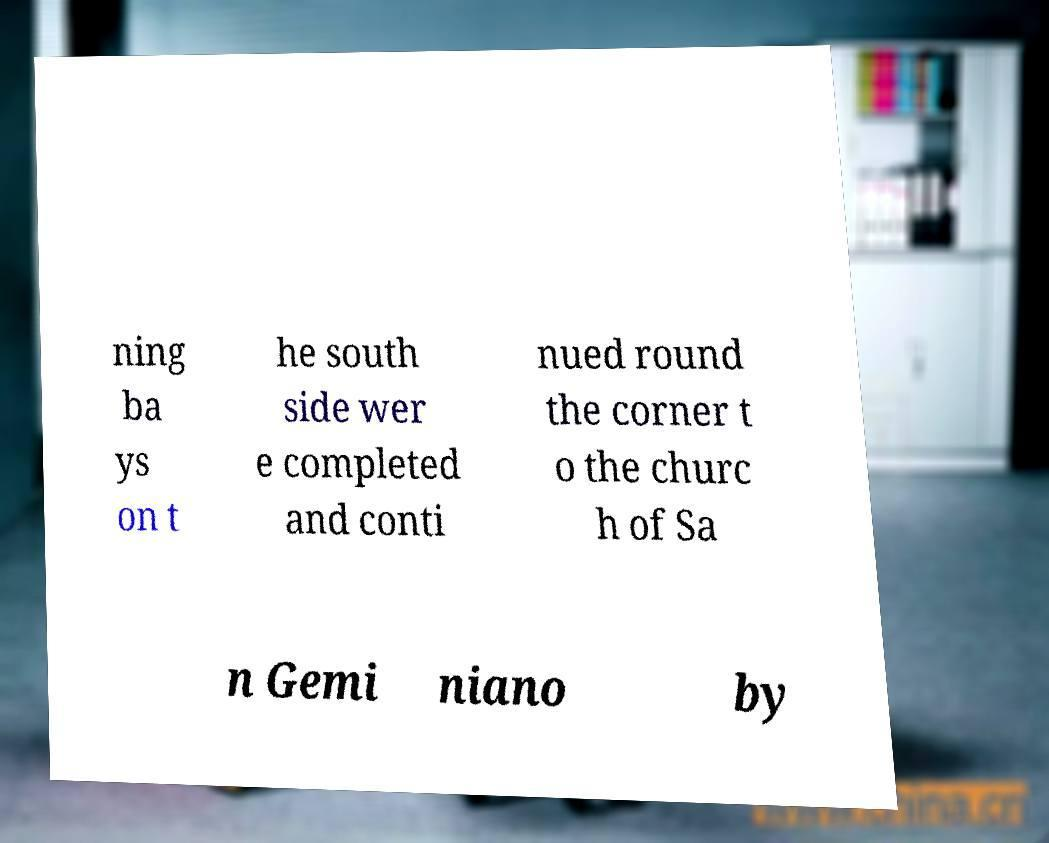Could you extract and type out the text from this image? ning ba ys on t he south side wer e completed and conti nued round the corner t o the churc h of Sa n Gemi niano by 